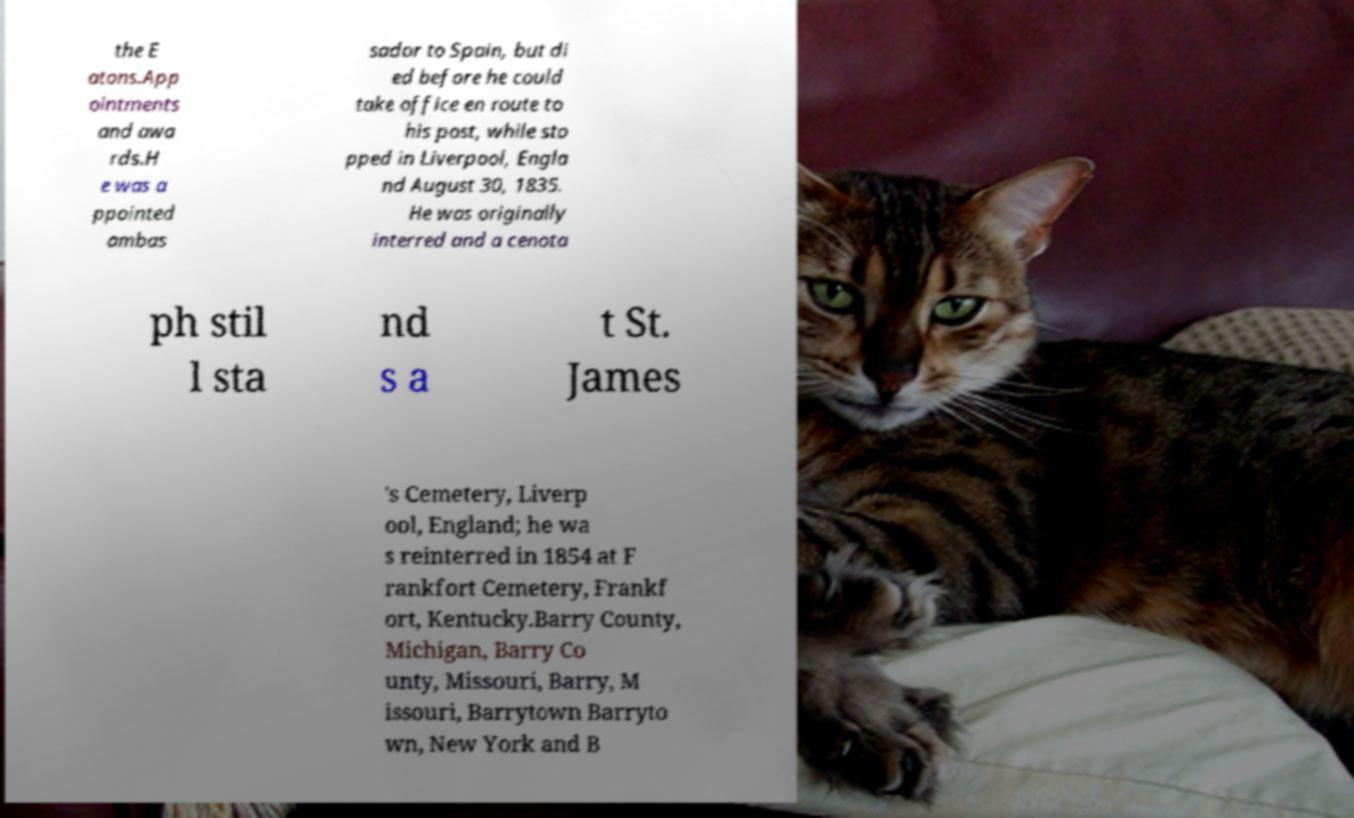Please read and relay the text visible in this image. What does it say? the E atons.App ointments and awa rds.H e was a ppointed ambas sador to Spain, but di ed before he could take office en route to his post, while sto pped in Liverpool, Engla nd August 30, 1835. He was originally interred and a cenota ph stil l sta nd s a t St. James 's Cemetery, Liverp ool, England; he wa s reinterred in 1854 at F rankfort Cemetery, Frankf ort, Kentucky.Barry County, Michigan, Barry Co unty, Missouri, Barry, M issouri, Barrytown Barryto wn, New York and B 